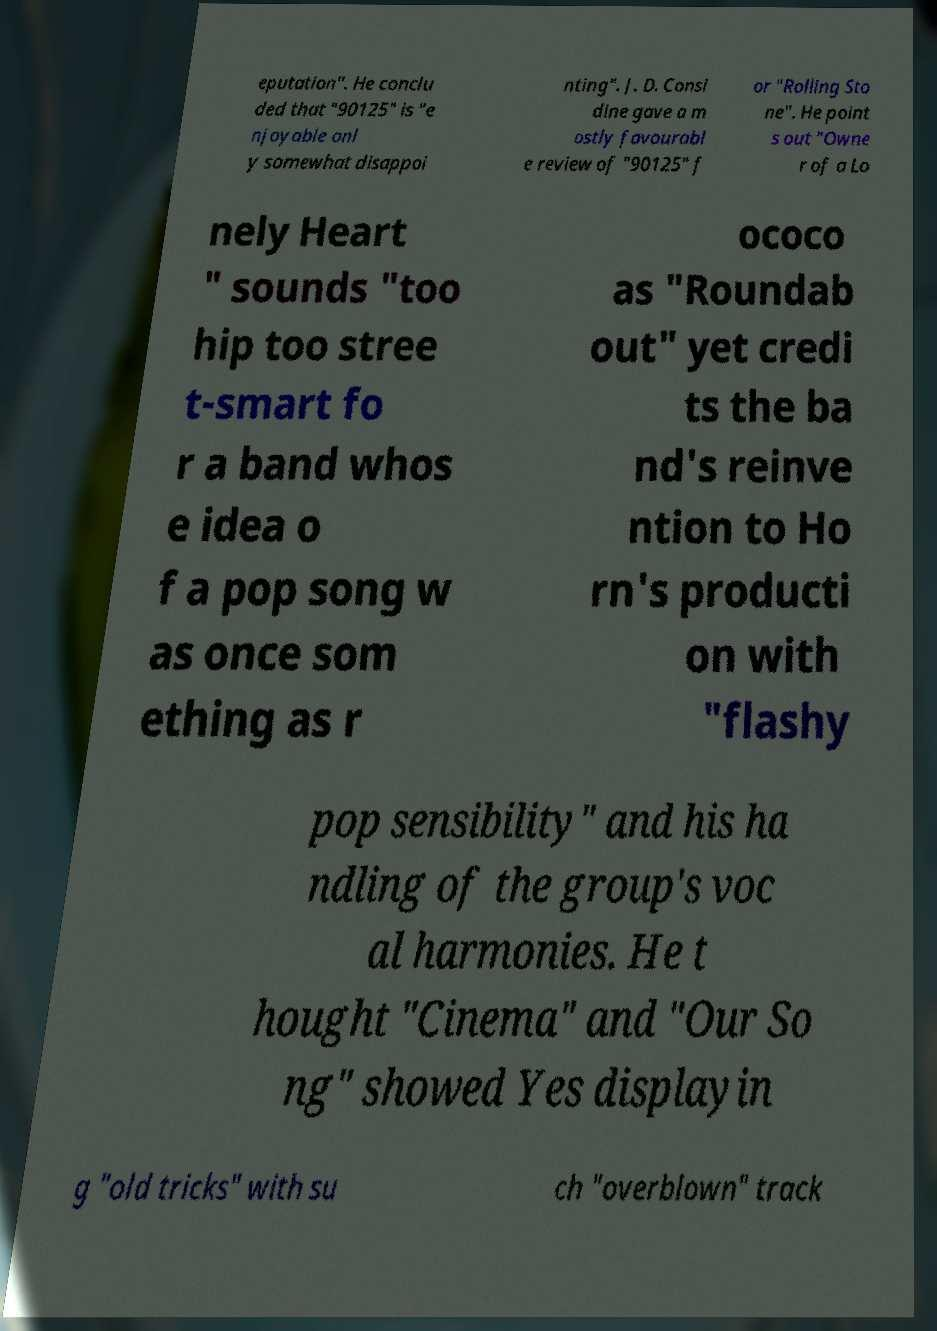What messages or text are displayed in this image? I need them in a readable, typed format. eputation". He conclu ded that "90125" is "e njoyable onl y somewhat disappoi nting". J. D. Consi dine gave a m ostly favourabl e review of "90125" f or "Rolling Sto ne". He point s out "Owne r of a Lo nely Heart " sounds "too hip too stree t-smart fo r a band whos e idea o f a pop song w as once som ething as r ococo as "Roundab out" yet credi ts the ba nd's reinve ntion to Ho rn's producti on with "flashy pop sensibility" and his ha ndling of the group's voc al harmonies. He t hought "Cinema" and "Our So ng" showed Yes displayin g "old tricks" with su ch "overblown" track 